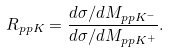<formula> <loc_0><loc_0><loc_500><loc_500>R _ { p p K } = \frac { d \sigma / d M _ { p p K ^ { - } } } { d \sigma / d M _ { p p K ^ { + } } } .</formula> 